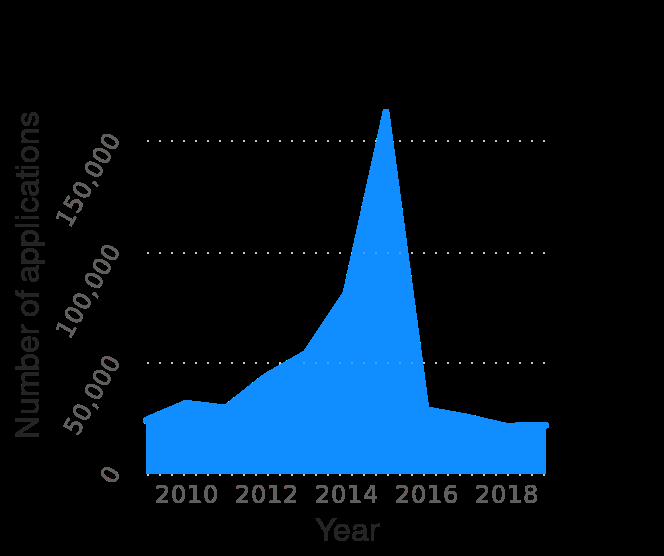<image>
What happened to the number of asylum applications between 2014 and 2016?  The number of asylum applications spiked between 2014 and 2016. Describe the following image in detail This area chart is called Number of asylum applications in Sweden from 2009 to 2019. On the y-axis, Number of applications is drawn on a linear scale with a minimum of 0 and a maximum of 150,000. A linear scale of range 2010 to 2018 can be found on the x-axis, labeled Year. What is the range of the x-axis? The range of the x-axis is from 2010 to 2018, representing the years. 